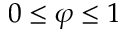Convert formula to latex. <formula><loc_0><loc_0><loc_500><loc_500>0 \leq \varphi \leq 1</formula> 